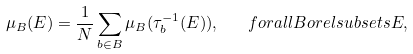Convert formula to latex. <formula><loc_0><loc_0><loc_500><loc_500>\mu _ { B } ( E ) = \frac { 1 } { N } \sum _ { b \in B } \mu _ { B } ( \tau _ { b } ^ { - 1 } ( E ) ) , \quad f o r a l l B o r e l s u b s e t s E ,</formula> 